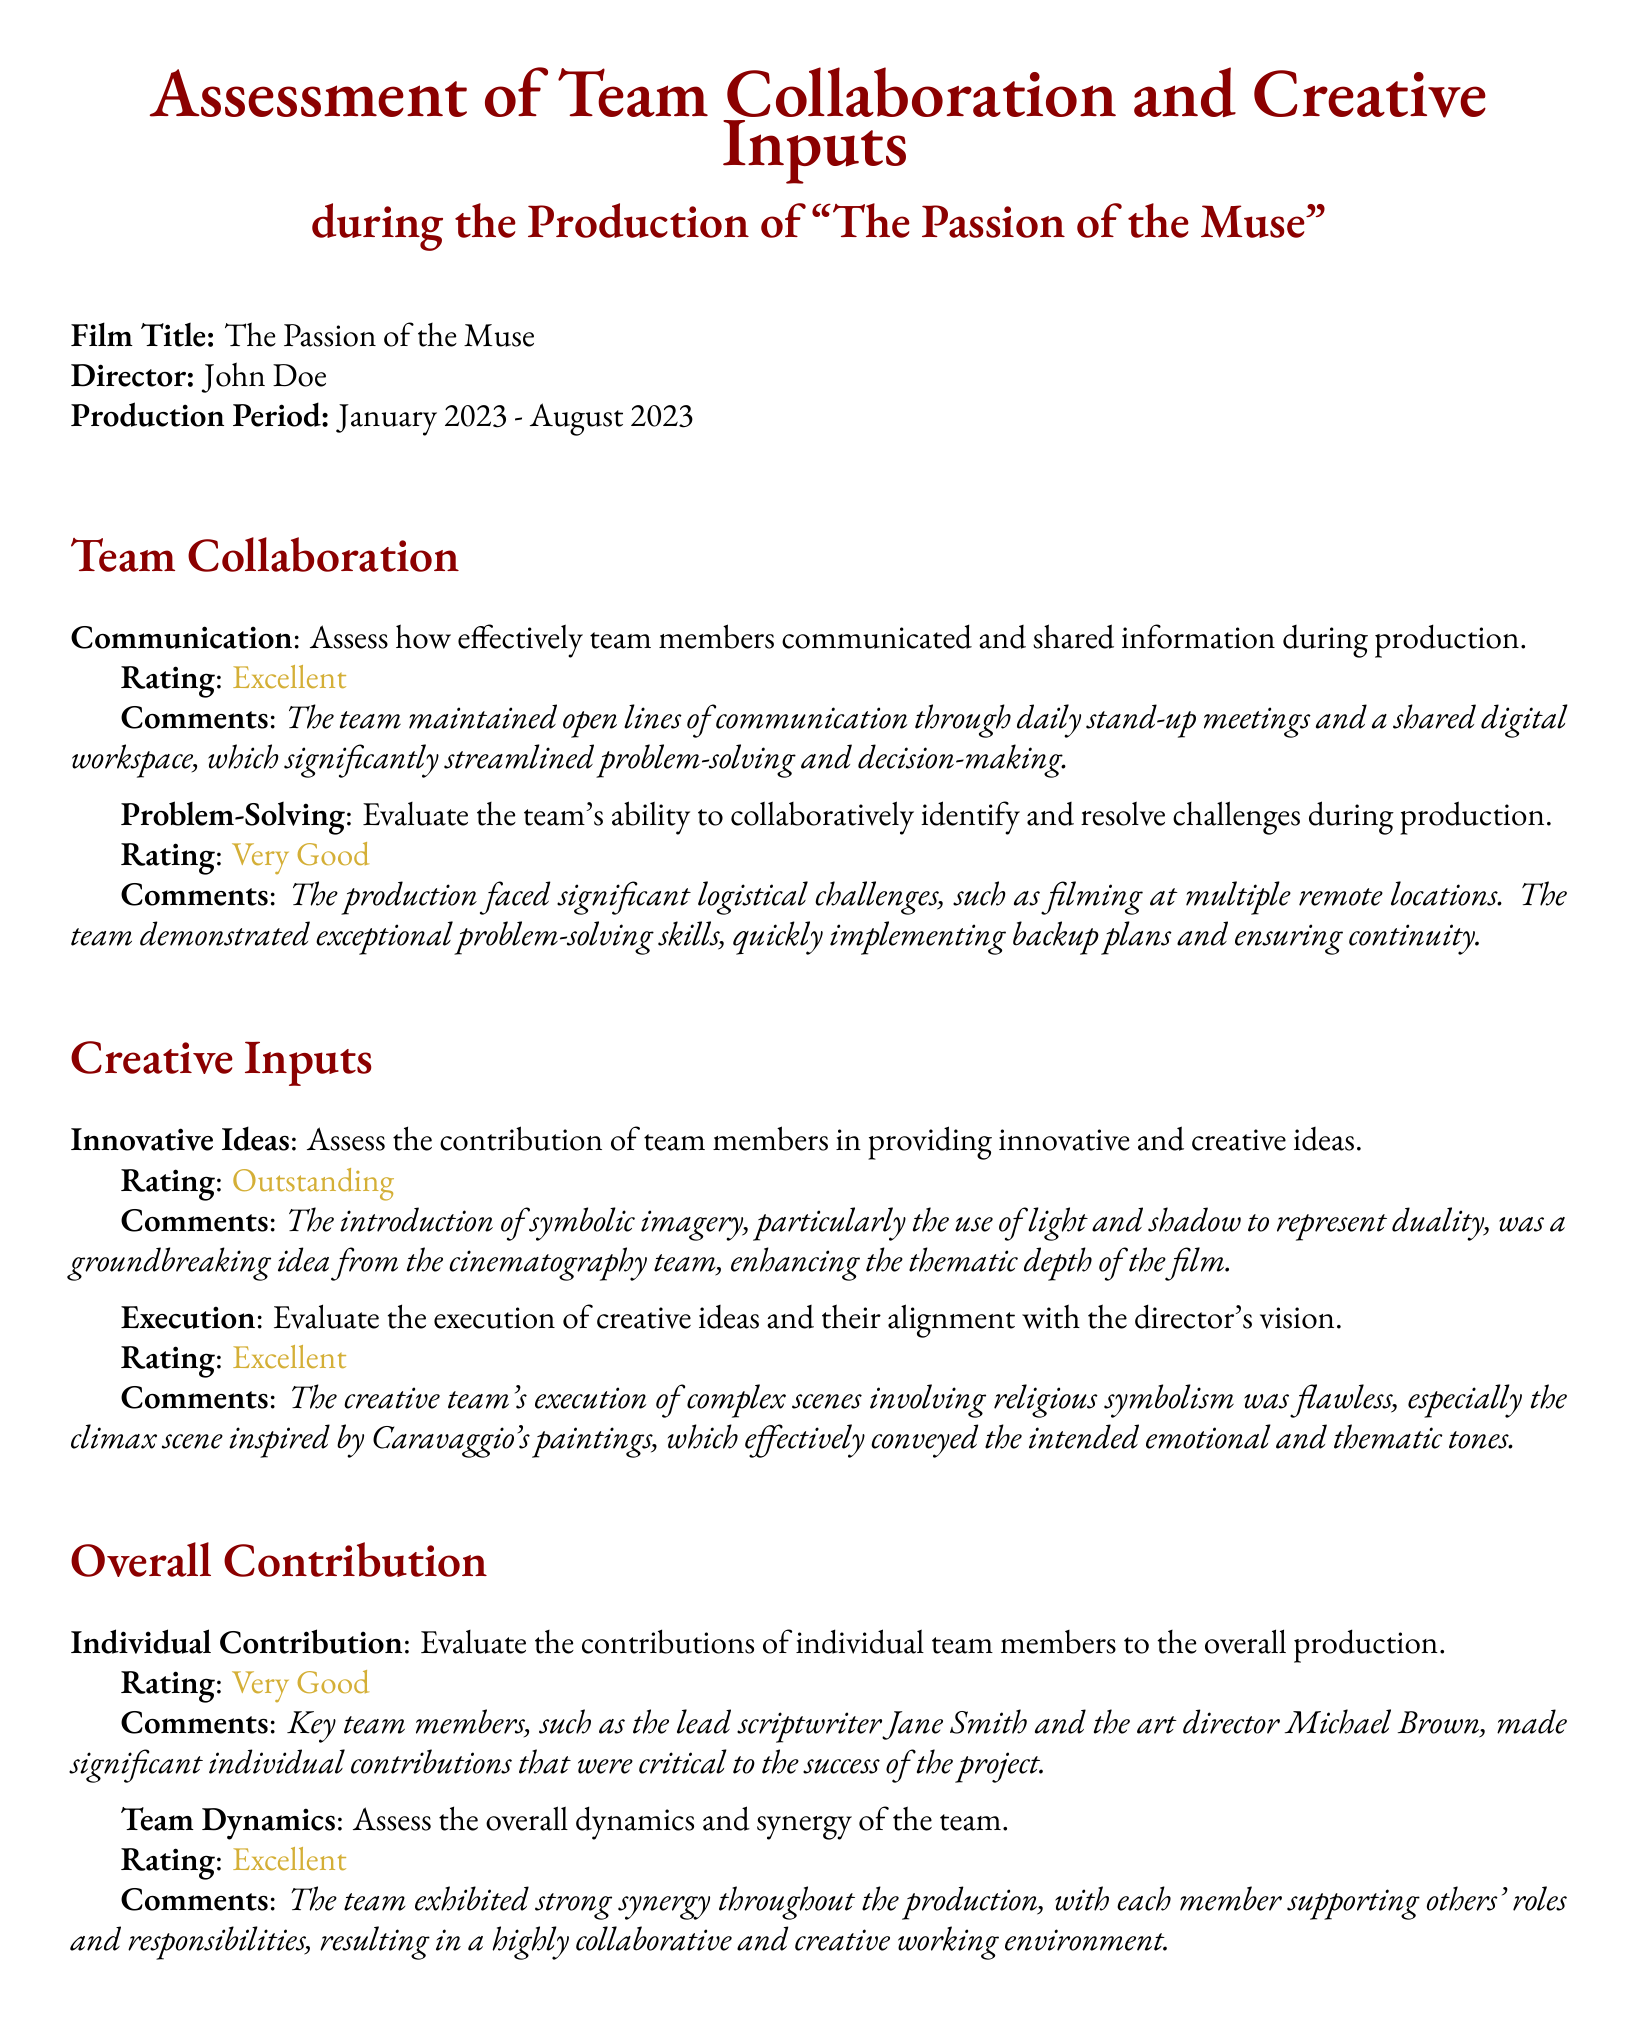What is the film title? The film title is indicated at the beginning of the document.
Answer: The Passion of the Muse Who is the director? The director's name is listed under the film title information.
Answer: John Doe What was the production period? The production period is specified in the document with start and end dates.
Answer: January 2023 - August 2023 What rating did the team receive for communication? The rating can be found in the "Team Collaboration" section under "Communication."
Answer: Excellent What innovative contribution came from the cinematography team? This contribution is described under "Creative Inputs" related to innovative ideas.
Answer: Symbolic imagery, particularly the use of light and shadow to represent duality Which key team member was mentioned for individual contribution? The document lists specific team members under the "Individual Contribution" criterion.
Answer: Jane Smith What was the rating for overall team dynamics? This rating can be found in the "Overall Contribution" section regarding team dynamics.
Answer: Excellent What inspired the climax scene in the film? The inspiration for the climax scene is noted in the "Execution" section of creative inputs.
Answer: Caravaggio's paintings What was the overall assessment of problem-solving abilities? The assessment is provided in the "Team Collaboration" section under problem-solving.
Answer: Very Good 